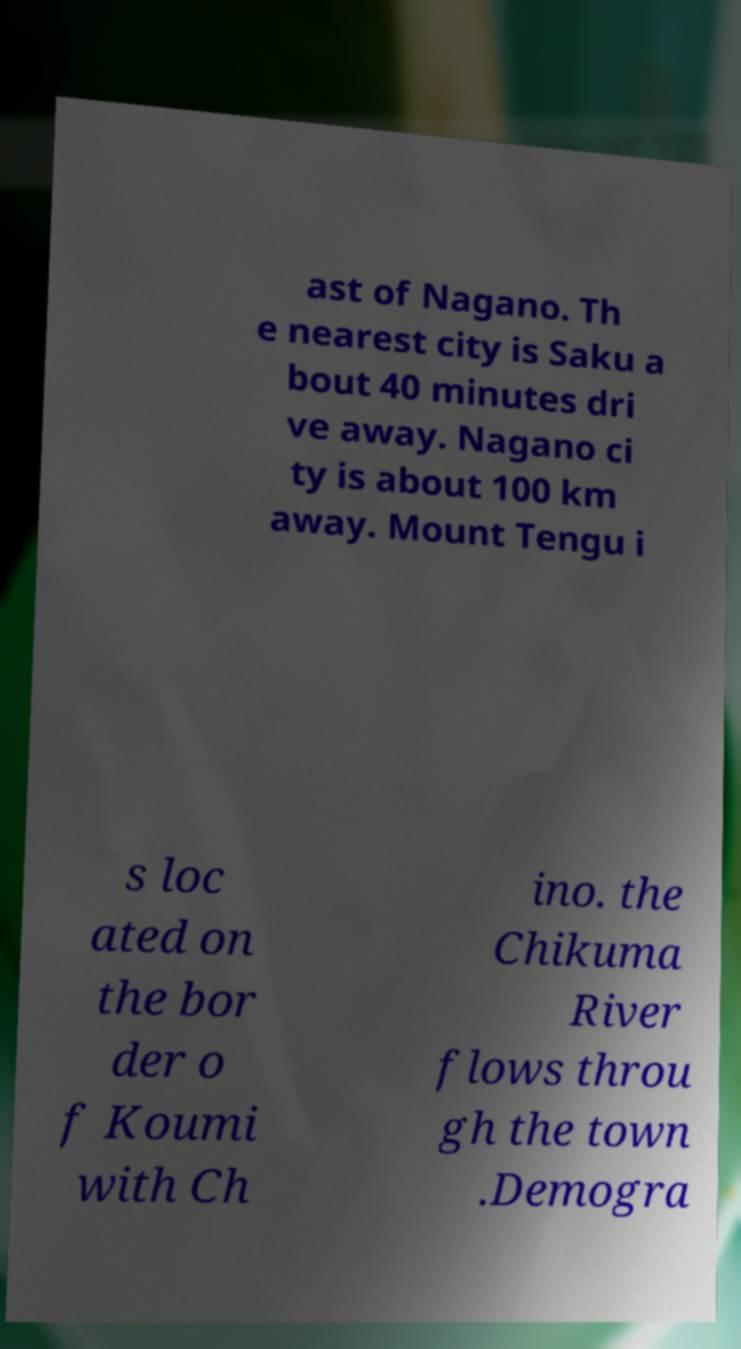Can you accurately transcribe the text from the provided image for me? ast of Nagano. Th e nearest city is Saku a bout 40 minutes dri ve away. Nagano ci ty is about 100 km away. Mount Tengu i s loc ated on the bor der o f Koumi with Ch ino. the Chikuma River flows throu gh the town .Demogra 